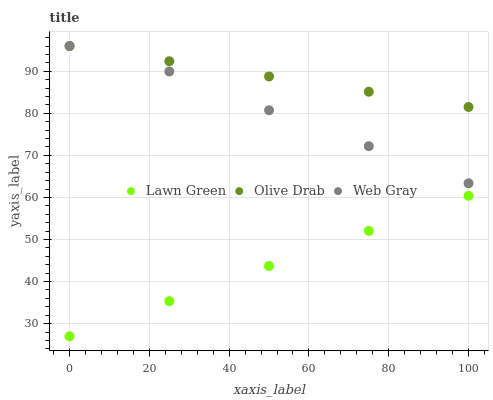Does Lawn Green have the minimum area under the curve?
Answer yes or no. Yes. Does Olive Drab have the maximum area under the curve?
Answer yes or no. Yes. Does Web Gray have the minimum area under the curve?
Answer yes or no. No. Does Web Gray have the maximum area under the curve?
Answer yes or no. No. Is Lawn Green the smoothest?
Answer yes or no. Yes. Is Web Gray the roughest?
Answer yes or no. Yes. Is Olive Drab the smoothest?
Answer yes or no. No. Is Olive Drab the roughest?
Answer yes or no. No. Does Lawn Green have the lowest value?
Answer yes or no. Yes. Does Web Gray have the lowest value?
Answer yes or no. No. Does Olive Drab have the highest value?
Answer yes or no. Yes. Is Lawn Green less than Web Gray?
Answer yes or no. Yes. Is Web Gray greater than Lawn Green?
Answer yes or no. Yes. Does Olive Drab intersect Web Gray?
Answer yes or no. Yes. Is Olive Drab less than Web Gray?
Answer yes or no. No. Is Olive Drab greater than Web Gray?
Answer yes or no. No. Does Lawn Green intersect Web Gray?
Answer yes or no. No. 